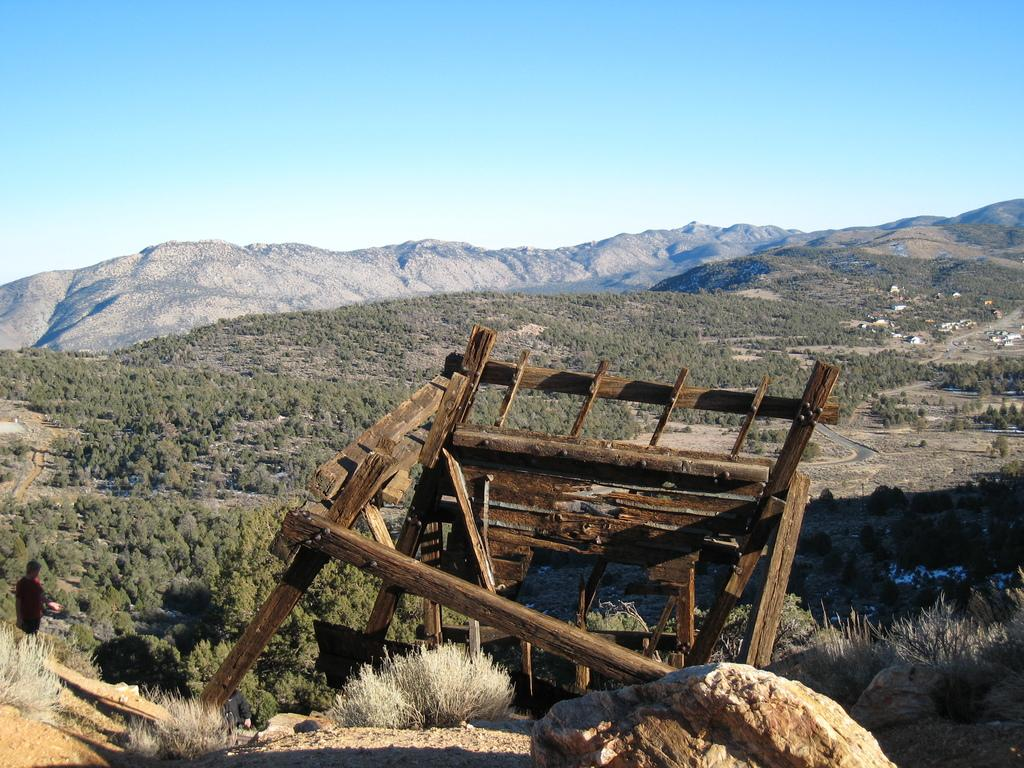What type of natural landscape can be seen in the image? There are hills in the image. What type of vegetation is present in the image? There are plants and grass in the image. Is there a person in the image? Yes, there is a person in the image. What kind of object made of wood can be seen in the image? There is a wooden object in the image. What other natural element is present in the image? There is a rock in the image. What part of the natural environment is visible in the image? The sky is visible in the image. What type of wine is being served in the image? There is no wine present in the image; it features a natural landscape with hills, plants, grass, a person, a wooden object, a rock, and a visible sky. 